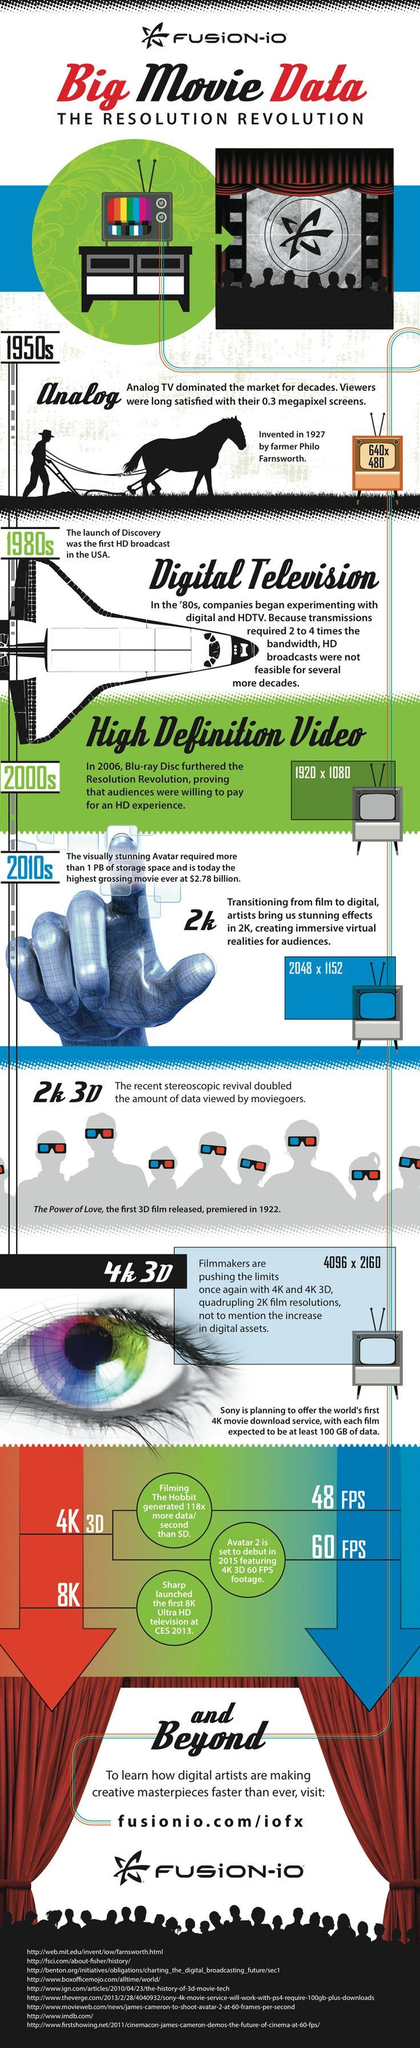Indicate a few pertinent items in this graphic. There are nine sources listed at the bottom. 8K is the latest digital resolution. The type of video with a resolution of 2048 x 1152 is referred to as 2K. The resolution of analog TV was 640 x 480 pixels. The resolution of high definition videos was 1920 x 1080 pixels. 